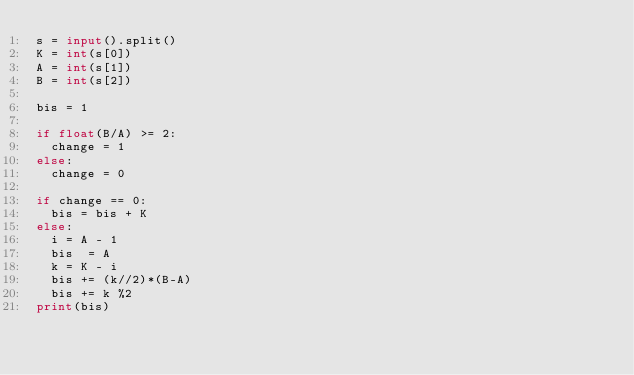Convert code to text. <code><loc_0><loc_0><loc_500><loc_500><_Python_>s = input().split()
K = int(s[0])
A = int(s[1])
B = int(s[2])
 
bis = 1
 
if float(B/A) >= 2:
  change = 1
else:
  change = 0
 
if change == 0:
  bis = bis + K
else:
  i = A - 1
  bis  = A
  k = K - i
  bis += (k//2)*(B-A)
  bis += k %2
print(bis)</code> 